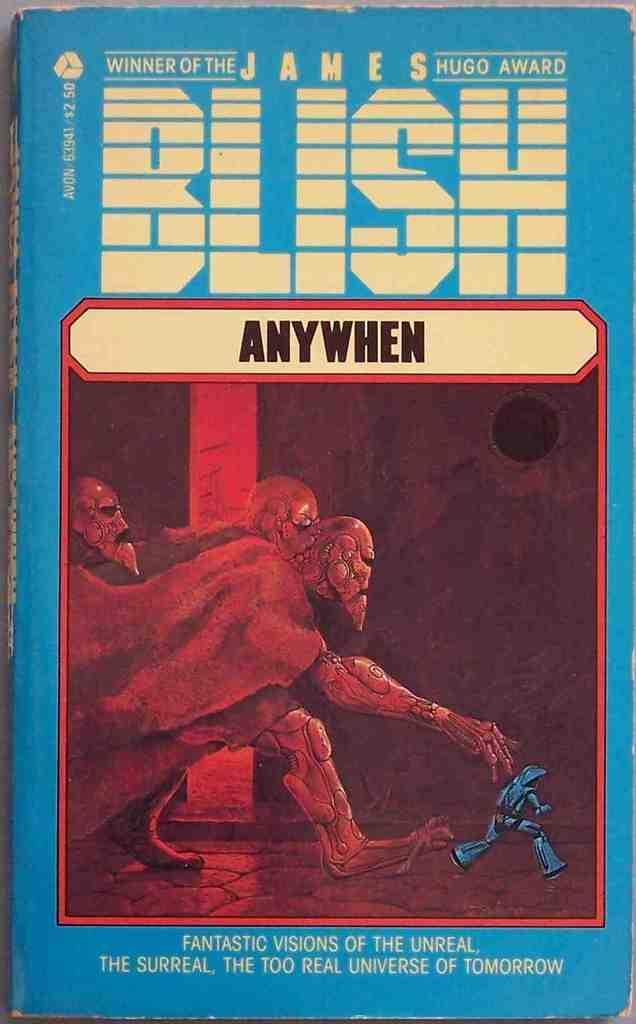Provide a one-sentence caption for the provided image. Anywhen is a book by James Blish that won the James Hugo Award. 